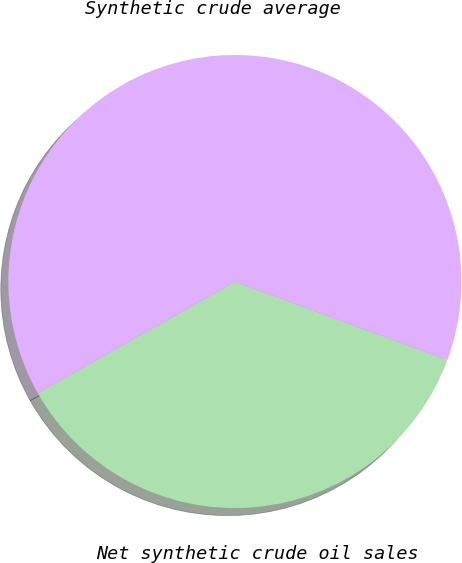<chart> <loc_0><loc_0><loc_500><loc_500><pie_chart><fcel>Net synthetic crude oil sales<fcel>Synthetic crude average<nl><fcel>36.18%<fcel>63.82%<nl></chart> 